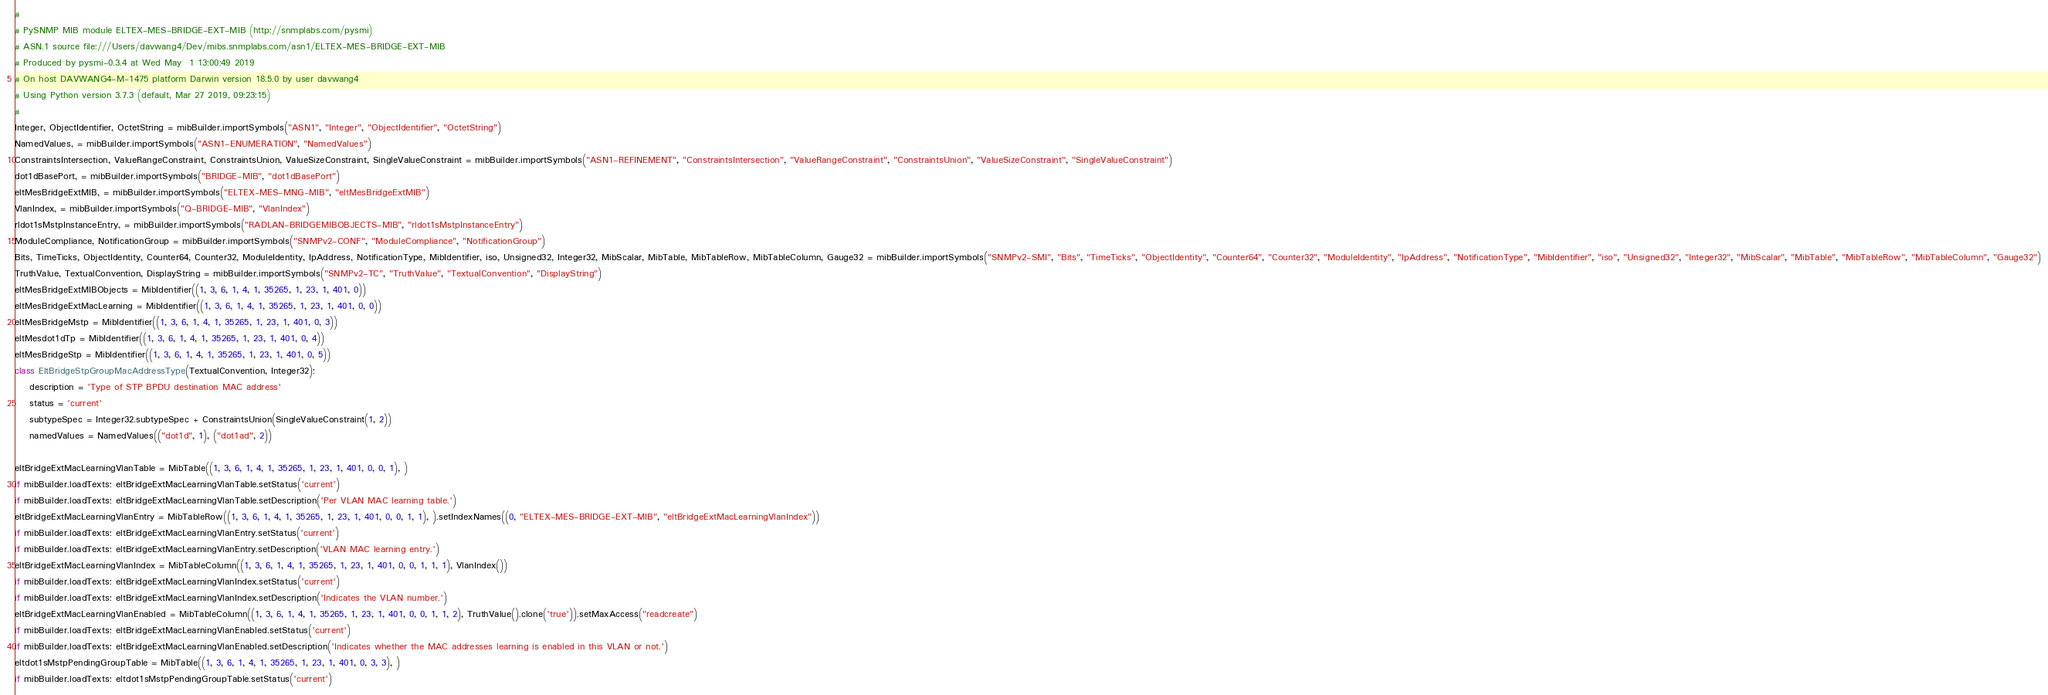<code> <loc_0><loc_0><loc_500><loc_500><_Python_>#
# PySNMP MIB module ELTEX-MES-BRIDGE-EXT-MIB (http://snmplabs.com/pysmi)
# ASN.1 source file:///Users/davwang4/Dev/mibs.snmplabs.com/asn1/ELTEX-MES-BRIDGE-EXT-MIB
# Produced by pysmi-0.3.4 at Wed May  1 13:00:49 2019
# On host DAVWANG4-M-1475 platform Darwin version 18.5.0 by user davwang4
# Using Python version 3.7.3 (default, Mar 27 2019, 09:23:15) 
#
Integer, ObjectIdentifier, OctetString = mibBuilder.importSymbols("ASN1", "Integer", "ObjectIdentifier", "OctetString")
NamedValues, = mibBuilder.importSymbols("ASN1-ENUMERATION", "NamedValues")
ConstraintsIntersection, ValueRangeConstraint, ConstraintsUnion, ValueSizeConstraint, SingleValueConstraint = mibBuilder.importSymbols("ASN1-REFINEMENT", "ConstraintsIntersection", "ValueRangeConstraint", "ConstraintsUnion", "ValueSizeConstraint", "SingleValueConstraint")
dot1dBasePort, = mibBuilder.importSymbols("BRIDGE-MIB", "dot1dBasePort")
eltMesBridgeExtMIB, = mibBuilder.importSymbols("ELTEX-MES-MNG-MIB", "eltMesBridgeExtMIB")
VlanIndex, = mibBuilder.importSymbols("Q-BRIDGE-MIB", "VlanIndex")
rldot1sMstpInstanceEntry, = mibBuilder.importSymbols("RADLAN-BRIDGEMIBOBJECTS-MIB", "rldot1sMstpInstanceEntry")
ModuleCompliance, NotificationGroup = mibBuilder.importSymbols("SNMPv2-CONF", "ModuleCompliance", "NotificationGroup")
Bits, TimeTicks, ObjectIdentity, Counter64, Counter32, ModuleIdentity, IpAddress, NotificationType, MibIdentifier, iso, Unsigned32, Integer32, MibScalar, MibTable, MibTableRow, MibTableColumn, Gauge32 = mibBuilder.importSymbols("SNMPv2-SMI", "Bits", "TimeTicks", "ObjectIdentity", "Counter64", "Counter32", "ModuleIdentity", "IpAddress", "NotificationType", "MibIdentifier", "iso", "Unsigned32", "Integer32", "MibScalar", "MibTable", "MibTableRow", "MibTableColumn", "Gauge32")
TruthValue, TextualConvention, DisplayString = mibBuilder.importSymbols("SNMPv2-TC", "TruthValue", "TextualConvention", "DisplayString")
eltMesBridgeExtMIBObjects = MibIdentifier((1, 3, 6, 1, 4, 1, 35265, 1, 23, 1, 401, 0))
eltMesBridgeExtMacLearning = MibIdentifier((1, 3, 6, 1, 4, 1, 35265, 1, 23, 1, 401, 0, 0))
eltMesBridgeMstp = MibIdentifier((1, 3, 6, 1, 4, 1, 35265, 1, 23, 1, 401, 0, 3))
eltMesdot1dTp = MibIdentifier((1, 3, 6, 1, 4, 1, 35265, 1, 23, 1, 401, 0, 4))
eltMesBridgeStp = MibIdentifier((1, 3, 6, 1, 4, 1, 35265, 1, 23, 1, 401, 0, 5))
class EltBridgeStpGroupMacAddressType(TextualConvention, Integer32):
    description = 'Type of STP BPDU destination MAC address'
    status = 'current'
    subtypeSpec = Integer32.subtypeSpec + ConstraintsUnion(SingleValueConstraint(1, 2))
    namedValues = NamedValues(("dot1d", 1), ("dot1ad", 2))

eltBridgeExtMacLearningVlanTable = MibTable((1, 3, 6, 1, 4, 1, 35265, 1, 23, 1, 401, 0, 0, 1), )
if mibBuilder.loadTexts: eltBridgeExtMacLearningVlanTable.setStatus('current')
if mibBuilder.loadTexts: eltBridgeExtMacLearningVlanTable.setDescription('Per VLAN MAC learning table.')
eltBridgeExtMacLearningVlanEntry = MibTableRow((1, 3, 6, 1, 4, 1, 35265, 1, 23, 1, 401, 0, 0, 1, 1), ).setIndexNames((0, "ELTEX-MES-BRIDGE-EXT-MIB", "eltBridgeExtMacLearningVlanIndex"))
if mibBuilder.loadTexts: eltBridgeExtMacLearningVlanEntry.setStatus('current')
if mibBuilder.loadTexts: eltBridgeExtMacLearningVlanEntry.setDescription('VLAN MAC learning entry.')
eltBridgeExtMacLearningVlanIndex = MibTableColumn((1, 3, 6, 1, 4, 1, 35265, 1, 23, 1, 401, 0, 0, 1, 1, 1), VlanIndex())
if mibBuilder.loadTexts: eltBridgeExtMacLearningVlanIndex.setStatus('current')
if mibBuilder.loadTexts: eltBridgeExtMacLearningVlanIndex.setDescription('Indicates the VLAN number.')
eltBridgeExtMacLearningVlanEnabled = MibTableColumn((1, 3, 6, 1, 4, 1, 35265, 1, 23, 1, 401, 0, 0, 1, 1, 2), TruthValue().clone('true')).setMaxAccess("readcreate")
if mibBuilder.loadTexts: eltBridgeExtMacLearningVlanEnabled.setStatus('current')
if mibBuilder.loadTexts: eltBridgeExtMacLearningVlanEnabled.setDescription('Indicates whether the MAC addresses learning is enabled in this VLAN or not.')
eltdot1sMstpPendingGroupTable = MibTable((1, 3, 6, 1, 4, 1, 35265, 1, 23, 1, 401, 0, 3, 3), )
if mibBuilder.loadTexts: eltdot1sMstpPendingGroupTable.setStatus('current')</code> 